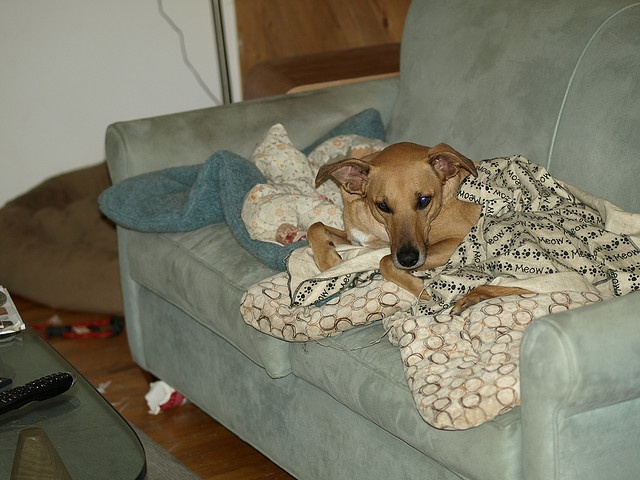Describe the objects in this image and their specific colors. I can see couch in darkgray and gray tones, dog in darkgray, olive, maroon, and tan tones, and remote in darkgray, black, darkgreen, and gray tones in this image. 